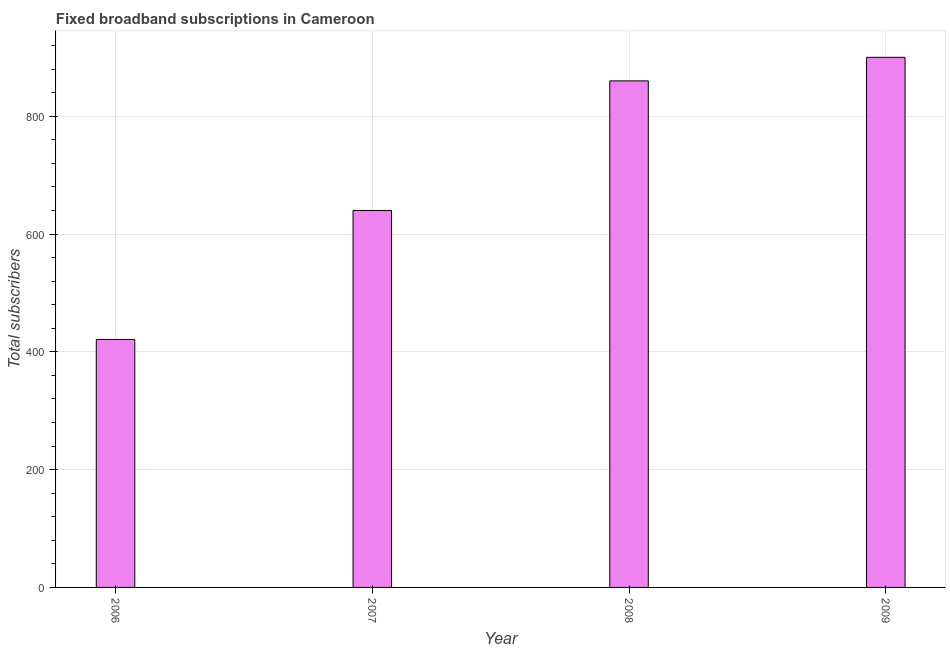Does the graph contain grids?
Offer a terse response. Yes. What is the title of the graph?
Give a very brief answer. Fixed broadband subscriptions in Cameroon. What is the label or title of the X-axis?
Your answer should be very brief. Year. What is the label or title of the Y-axis?
Keep it short and to the point. Total subscribers. What is the total number of fixed broadband subscriptions in 2006?
Offer a terse response. 421. Across all years, what is the maximum total number of fixed broadband subscriptions?
Provide a short and direct response. 900. Across all years, what is the minimum total number of fixed broadband subscriptions?
Make the answer very short. 421. In which year was the total number of fixed broadband subscriptions maximum?
Your answer should be compact. 2009. In which year was the total number of fixed broadband subscriptions minimum?
Keep it short and to the point. 2006. What is the sum of the total number of fixed broadband subscriptions?
Give a very brief answer. 2821. What is the difference between the total number of fixed broadband subscriptions in 2007 and 2008?
Make the answer very short. -220. What is the average total number of fixed broadband subscriptions per year?
Your answer should be very brief. 705. What is the median total number of fixed broadband subscriptions?
Provide a short and direct response. 750. What is the ratio of the total number of fixed broadband subscriptions in 2006 to that in 2007?
Your answer should be compact. 0.66. Is the total number of fixed broadband subscriptions in 2006 less than that in 2009?
Offer a very short reply. Yes. Is the difference between the total number of fixed broadband subscriptions in 2007 and 2009 greater than the difference between any two years?
Make the answer very short. No. What is the difference between the highest and the second highest total number of fixed broadband subscriptions?
Offer a terse response. 40. Is the sum of the total number of fixed broadband subscriptions in 2007 and 2008 greater than the maximum total number of fixed broadband subscriptions across all years?
Your response must be concise. Yes. What is the difference between the highest and the lowest total number of fixed broadband subscriptions?
Offer a very short reply. 479. In how many years, is the total number of fixed broadband subscriptions greater than the average total number of fixed broadband subscriptions taken over all years?
Ensure brevity in your answer.  2. Are all the bars in the graph horizontal?
Make the answer very short. No. What is the Total subscribers of 2006?
Make the answer very short. 421. What is the Total subscribers in 2007?
Provide a succinct answer. 640. What is the Total subscribers in 2008?
Your response must be concise. 860. What is the Total subscribers in 2009?
Provide a succinct answer. 900. What is the difference between the Total subscribers in 2006 and 2007?
Ensure brevity in your answer.  -219. What is the difference between the Total subscribers in 2006 and 2008?
Your answer should be very brief. -439. What is the difference between the Total subscribers in 2006 and 2009?
Your response must be concise. -479. What is the difference between the Total subscribers in 2007 and 2008?
Keep it short and to the point. -220. What is the difference between the Total subscribers in 2007 and 2009?
Make the answer very short. -260. What is the ratio of the Total subscribers in 2006 to that in 2007?
Your response must be concise. 0.66. What is the ratio of the Total subscribers in 2006 to that in 2008?
Your answer should be very brief. 0.49. What is the ratio of the Total subscribers in 2006 to that in 2009?
Offer a terse response. 0.47. What is the ratio of the Total subscribers in 2007 to that in 2008?
Offer a very short reply. 0.74. What is the ratio of the Total subscribers in 2007 to that in 2009?
Offer a very short reply. 0.71. What is the ratio of the Total subscribers in 2008 to that in 2009?
Your response must be concise. 0.96. 